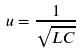Convert formula to latex. <formula><loc_0><loc_0><loc_500><loc_500>u = \frac { 1 } { \sqrt { L C } }</formula> 